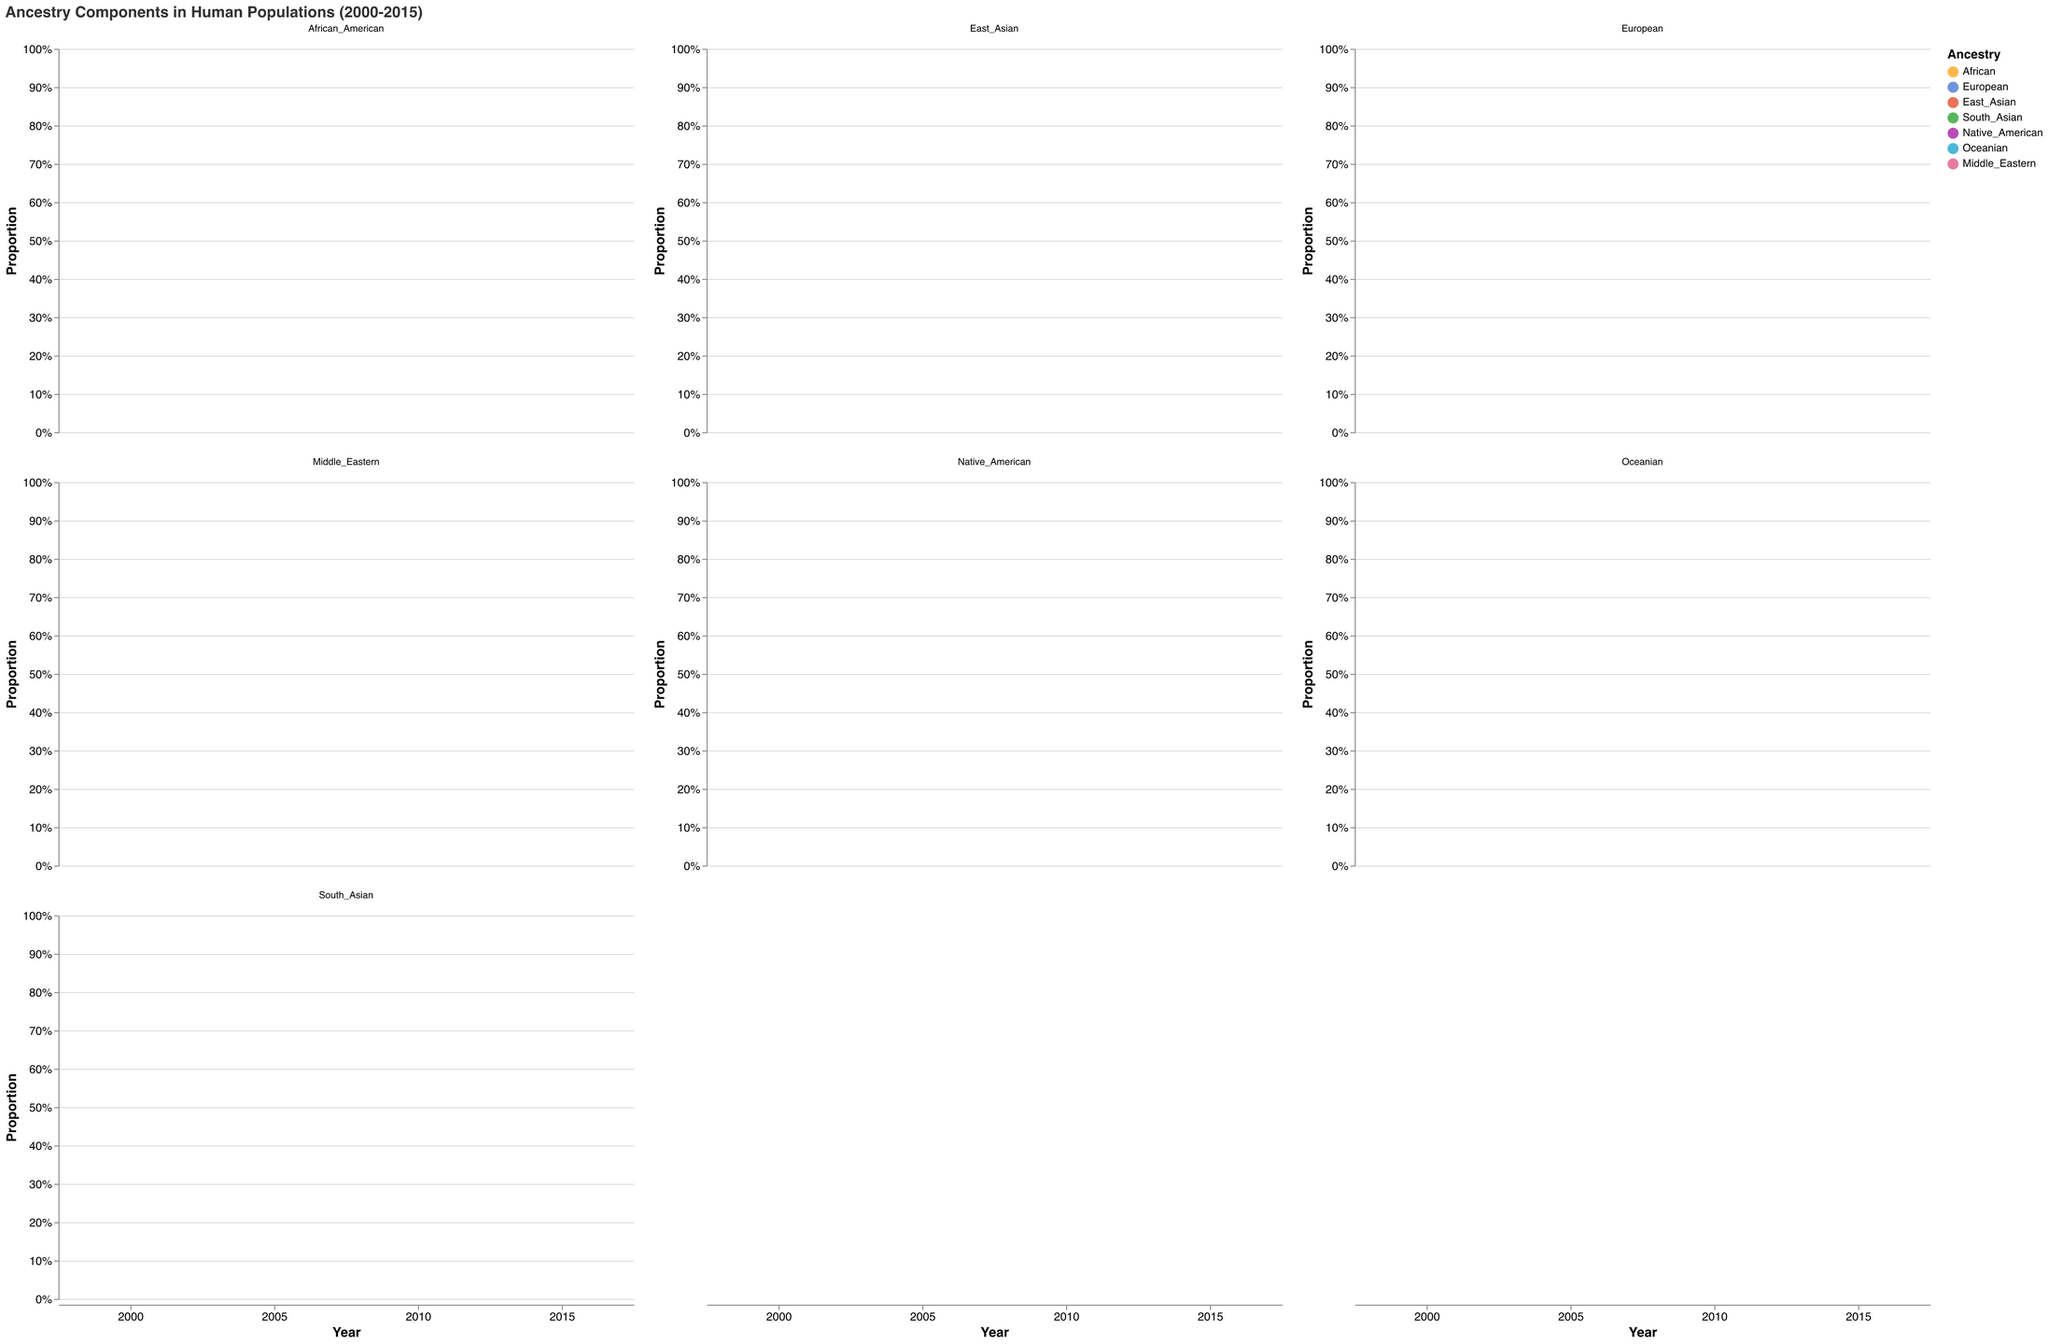What is the title of the figure? The title is displayed at the top of the figure. It is "Ancestry Components in Human Populations (2000-2015)" in large font.
Answer: Ancestry Components in Human Populations (2000-2015) Which ancestry component is represented by the color "#3366CC"? The color legend on the right side of the figure associates colors with ancestry components. The color "#3366CC" corresponds to "European".
Answer: European In which year did the African_American population have the highest proportion of European ancestry? Observe the stacked area chart for the African_American population and compare the size of the European segment (color-coded) across different years. The year 2015 has the largest visually identifiable proportion.
Answer: 2015 How has the proportion of Native_American ancestry changed in the East_Asian population from 2000 to 2015? In the East_Asian population subplot, the area representing Native_American ancestry (color) is increasing from 2000 to 2015. In 2000, the proportion is 0%, and in 2015, it reaches 3%.
Answer: Increased from 0% to 3% Which population has shown an increase in both Oceanian and Middle_Eastern ancestries from 2000 to 2015? Inspect all population subplots and identify which ones have both Oceanian and Middle_Eastern components increasing. The African_American population demonstrates this trend.
Answer: African_American What is the most dominant ancestry component in the Native_American population throughout the years 2000 to 2015? Examine the Native_American population subplot. The largest area segment each year is Native_American (specifically color-coded). This component remains the most dominant throughout the years.
Answer: Native_American Which ancestry group shows the most stable proportions across all populations from 2000 to 2015? Observe the trends of each ancestry component across all populations. The European ancestry component appears the most stable compared to others, especially in populations not primarily composed of European ancestry.
Answer: European How does the African ancestry component in the European population compare between 2000 and 2015? Look at the European population subplot and compare the African ancestry proportions for the years 2000 and 2015. The proportion remains constant at 1%.
Answer: It remains constant at 1% In the South_Asian population, how has the East_Asian ancestry proportion changed from 2000 to 2015? Analyze the South_Asian population subplot specifically for the East_Asian area (color). The East_Asian ancestry changes from 2% in 2000 to 3% in 2015.
Answer: Increased from 2% to 3% Which population shows the greatest diversity in ancestry components in 2015? Compare the proportions of different ancestry components in 2015 across all populations. The African_American population has the largest diversity as it includes all components with significant proportions.
Answer: African_American 